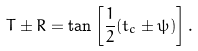Convert formula to latex. <formula><loc_0><loc_0><loc_500><loc_500>T \pm R = \tan \left [ \frac { 1 } { 2 } ( t _ { c } \pm \psi ) \right ] .</formula> 